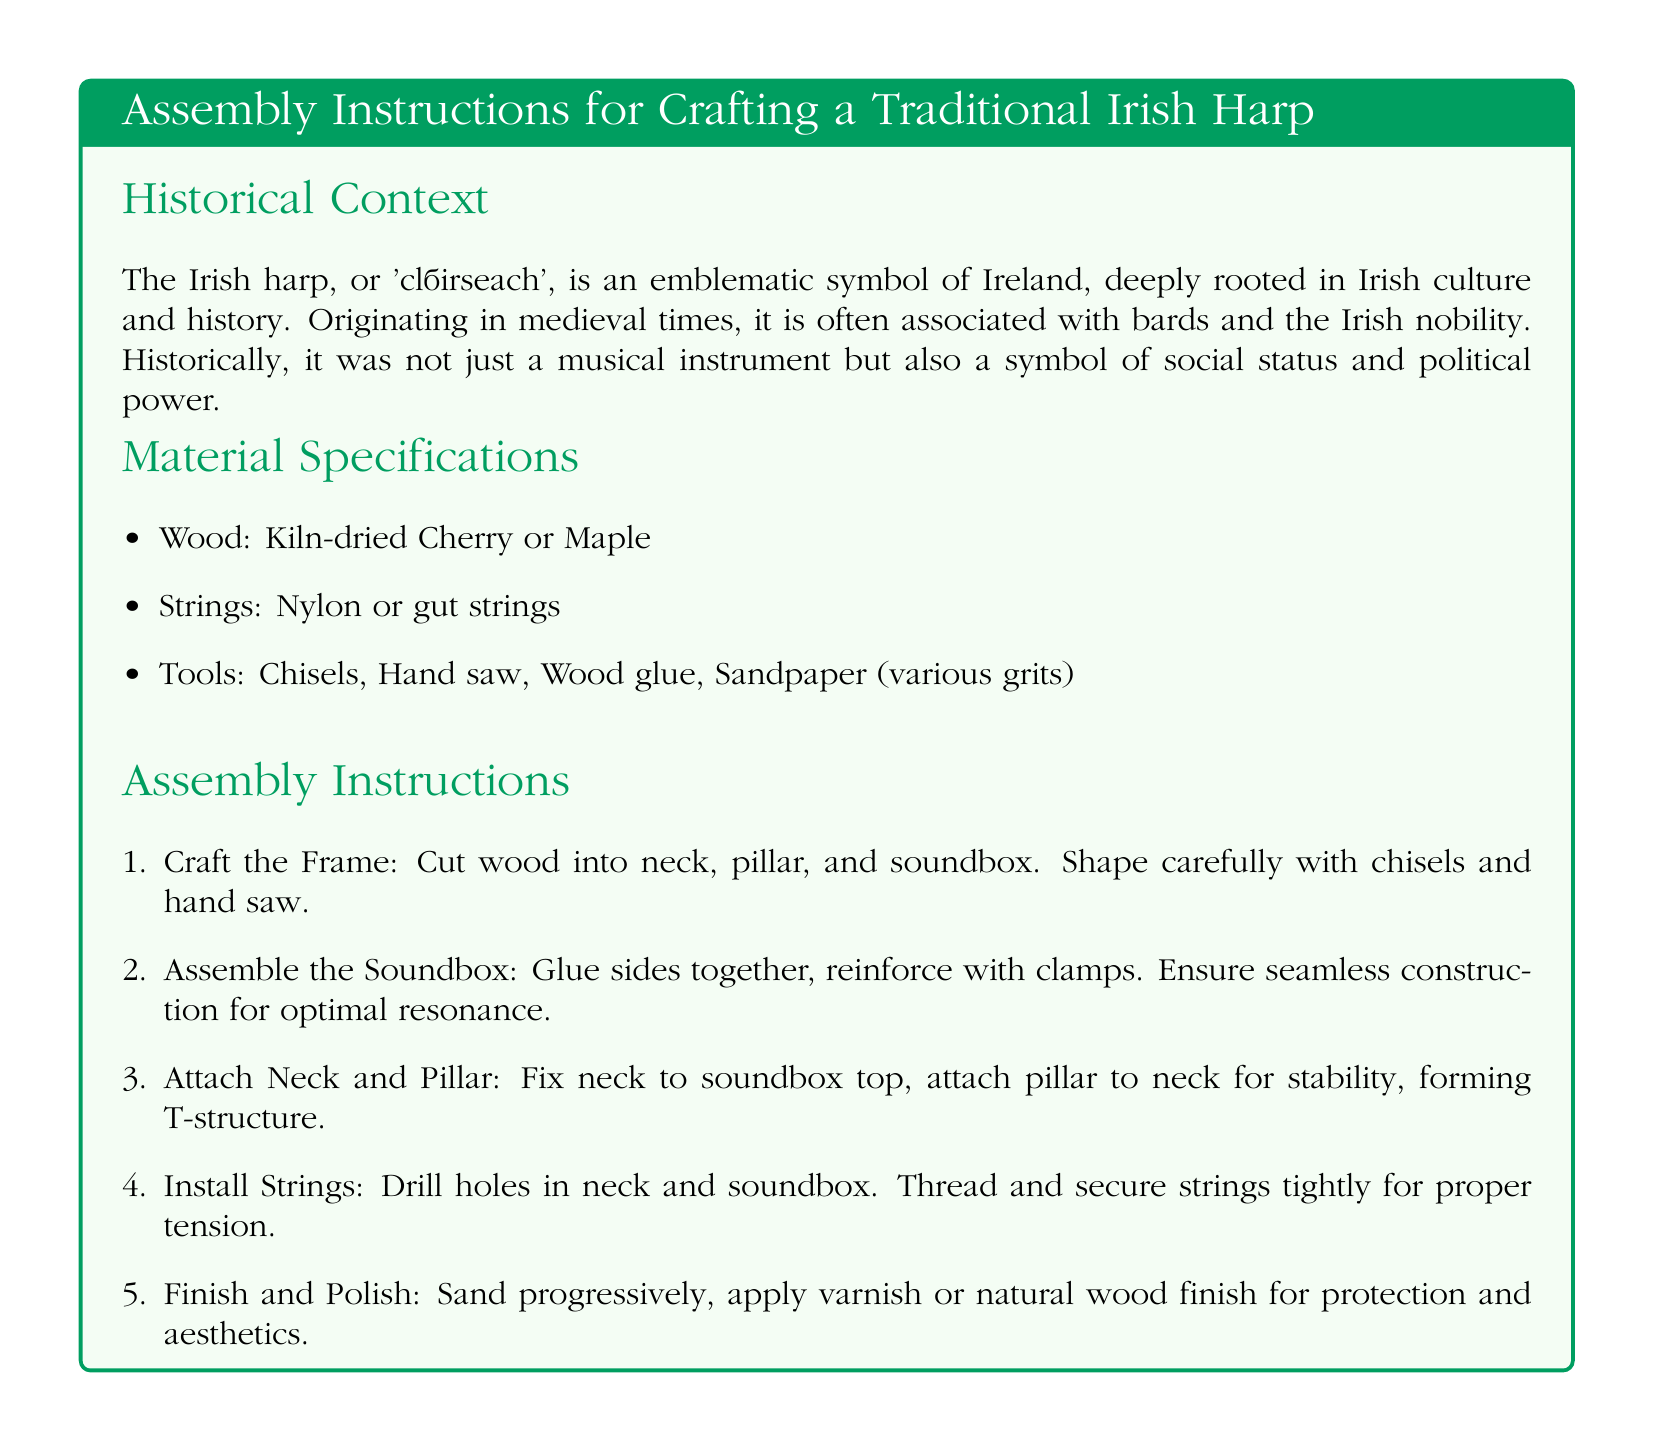What is the Irish term for harp? The document specifies that the Irish harp is known as 'cláirseach'.
Answer: 'cláirseach' What types of wood are recommended? The material specifications outline that kiln-dried Cherry or Maple are the recommended woods.
Answer: Cherry or Maple How many tools are listed? The document enumerates three types of tools needed for assembly.
Answer: Three What is the purpose of the soundbox in the assembly? The assembly instructions imply that the soundbox needs to be constructed for optimal resonance.
Answer: Optimal resonance What is the first step in assembly? The document states that the first step involves crafting the frame by cutting wood into parts.
Answer: Craft the Frame What materials are used for strings? The material specifications indicate that nylon or gut strings are used.
Answer: Nylon or gut strings What is the structure formed when the neck and pillar are attached? The assembly instructions state that fixing the neck to the soundbox top and attaching the pillar form a T-structure.
Answer: T-structure What finishing material is suggested in the last assembly step? The final step in the instructions mentions applying varnish or natural wood finish for protection.
Answer: Varnish or natural wood finish What is the color used for section titles? The document specifies that section titles are colored in Irish green.
Answer: Irish green What aspect does the historical context highlight about the harp? The historical context emphasizes that the harp was a symbol of social status and political power.
Answer: Social status and political power 